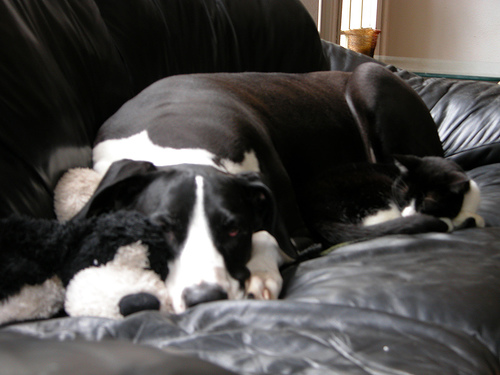Is the focus blurry?
A. Yes
B. No
Answer with the option's letter from the given choices directly.
 B. 